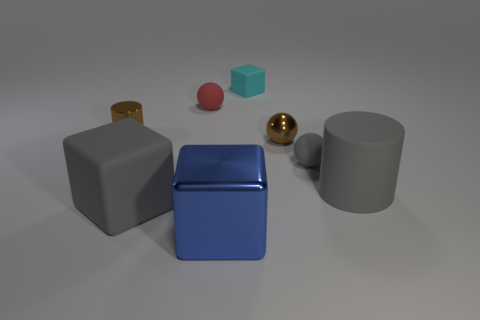There is a cube that is behind the blue metal block and to the left of the small cyan rubber object; what color is it?
Ensure brevity in your answer.  Gray. Are there more small cyan rubber objects than big shiny cylinders?
Your answer should be compact. Yes. What number of things are tiny green rubber objects or rubber balls that are in front of the metallic cylinder?
Offer a very short reply. 1. Is the size of the red matte thing the same as the cyan cube?
Provide a succinct answer. Yes. Are there any brown cylinders on the right side of the cyan rubber block?
Provide a succinct answer. No. There is a metal thing that is both behind the big shiny object and to the right of the tiny red ball; what size is it?
Offer a very short reply. Small. What number of objects are large blue metal things or brown metallic spheres?
Offer a terse response. 2. There is a shiny cylinder; is its size the same as the rubber sphere to the left of the gray rubber sphere?
Give a very brief answer. Yes. There is a cube behind the small brown thing in front of the brown object left of the small cyan block; how big is it?
Offer a terse response. Small. Is there a small yellow ball?
Offer a very short reply. No. 